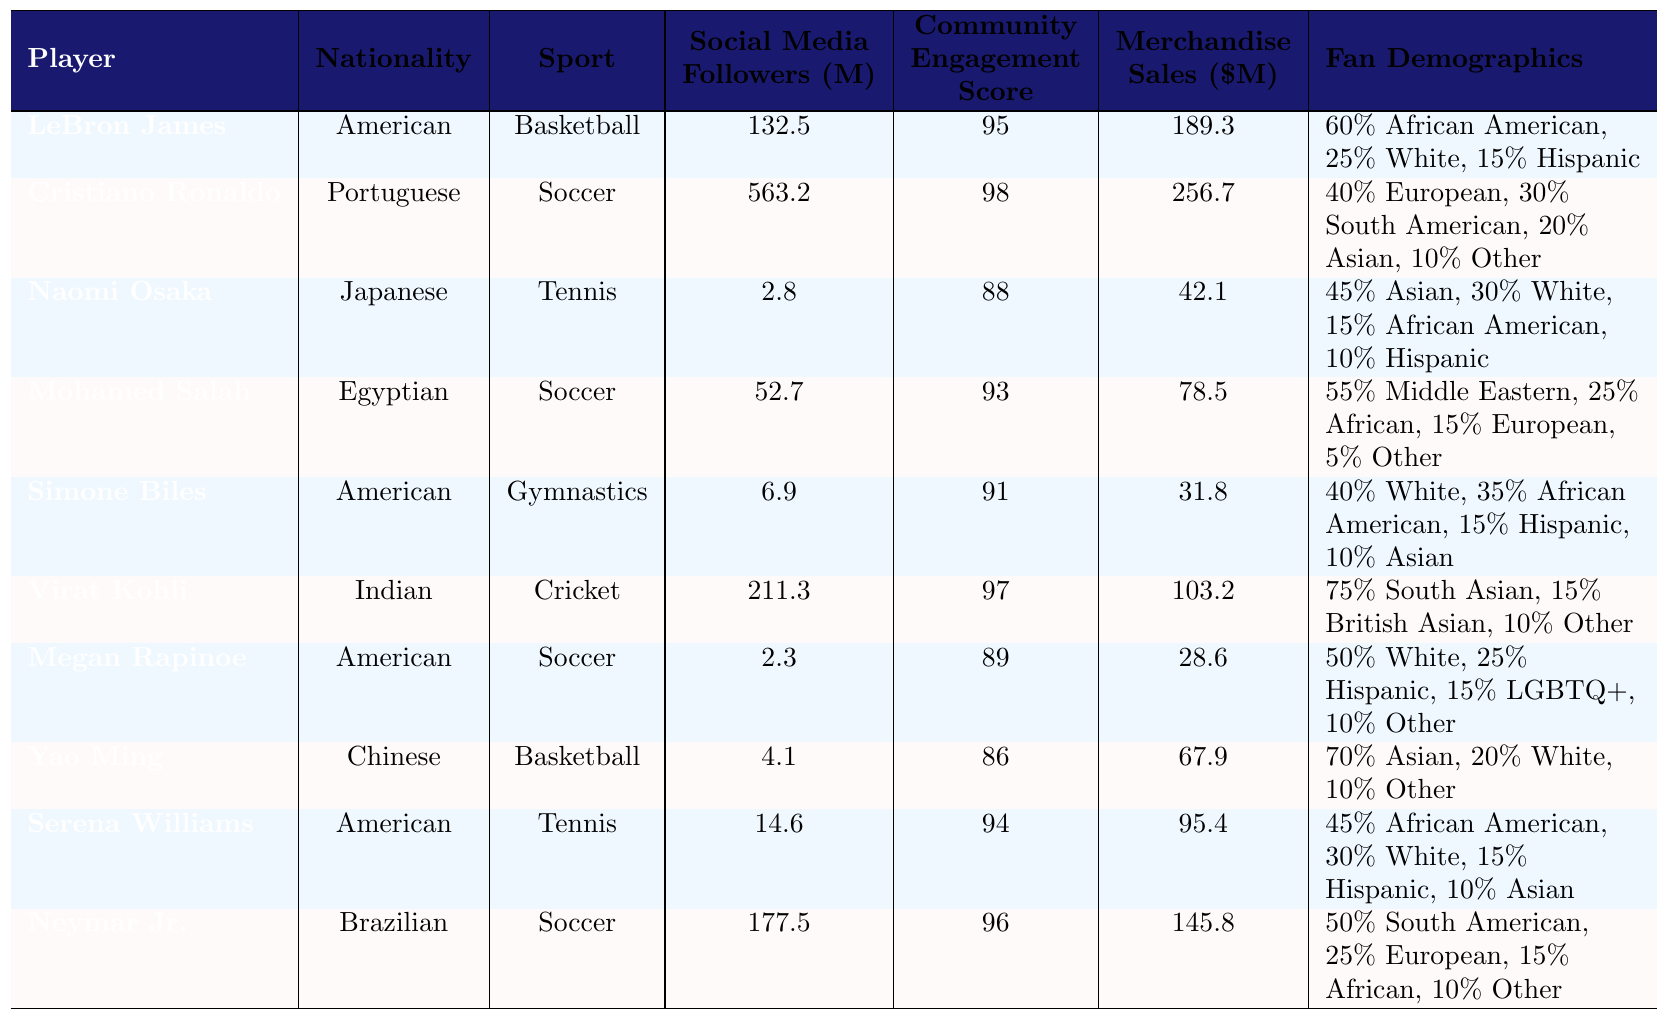What is the nationality of LeBron James? The table indicates that LeBron James is listed with the nationality "American."
Answer: American Which player has the highest social media followers? By comparing the "Social Media Followers" column, Cristiano Ronaldo has the highest value of 563.2 million followers.
Answer: Cristiano Ronaldo What is the community engagement score of Serena Williams? According to the table, Serena Williams has a community engagement score of 94.
Answer: 94 Which sport has the average merchandise sales greater than $100 million, based on the players listed? The merchandise sales for players in soccer (Cristiano Ronaldo, Mohamed Salah, Neymar Jr.) average to (256.7 + 78.5 + 145.8) / 3 = 160.3 million, while basketball (LeBron James, Yao Ming) averages (189.3 + 67.9) / 2 = 128.6 million, both are above $100 million. The average for cricket (Virat Kohli) is 103.2 million, and for gymnastics (Simone Biles, Megan Rapinoe) it's below. Thus, both basketball and soccer have averages over $100 million.
Answer: Soccer and Basketball Is the fan demographic of Mohamed Salah predominantly Middle Eastern? The data shows that 55% of Mohamed Salah's fan demographic is Middle Eastern, indicating it is the majority.
Answer: Yes How many players have a community engagement score above 90? By examining the scores, players with scores above 90 are Cristiano Ronaldo, Mohamed Salah, Virat Kohli, LeBron James, Serena Williams, and Simone Biles. This totals to 6 players.
Answer: 6 Which player has the lowest merchandise sales, and what is the value? Looking through the "Merchandise Sales" column, Megan Rapinoe has the lowest sales, which amount to 28.6 million dollars.
Answer: Megan Rapinoe, 28.6 million What is the combined social media following of players from American nationality? The players from American nationality are LeBron James (132.5), Simone Biles (6.9), Megan Rapinoe (2.3), and Serena Williams (14.6). Their combined following is 132.5 + 6.9 + 2.3 + 14.6 = 156.3 million.
Answer: 156.3 million Are there more players from European countries or Asian countries based on their nationality in the table? The players from European countries include Cristiano Ronaldo (Portugal), and Neymar Jr. (Brazil) counts a portion. Asian players include Naomi Osaka (Japan), Yao Ming (China), and Virat Kohli (India). Counting the main players, there are 3 from Asia and a total of 2 from Europe, with Neymar being from a South American country. Given the key players in consideration, Asia has the majority.
Answer: More from Asia What percentage of fan demographics does Neymar Jr. have that is South American? Neymar Jr.'s fan demographics indicate 50% of his fans are South American, which is a clear percentage stated in the table.
Answer: 50% 